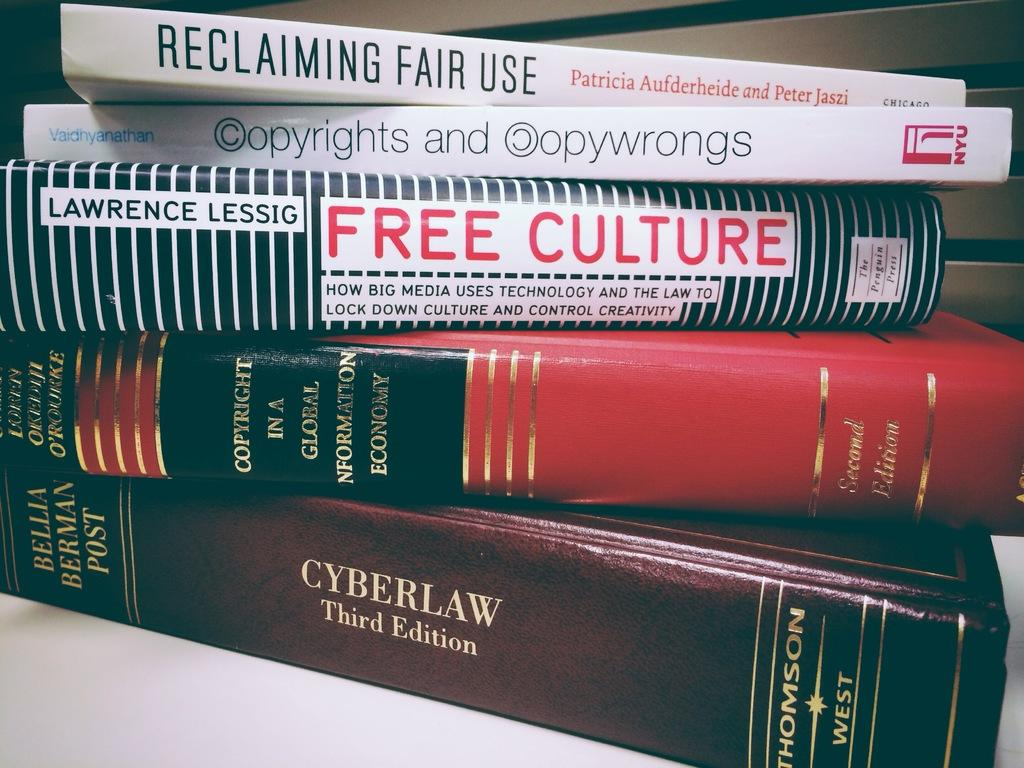<image>
Present a compact description of the photo's key features. Books stacked on top of one another with the one on the bottom saying "CYBERLAW". 